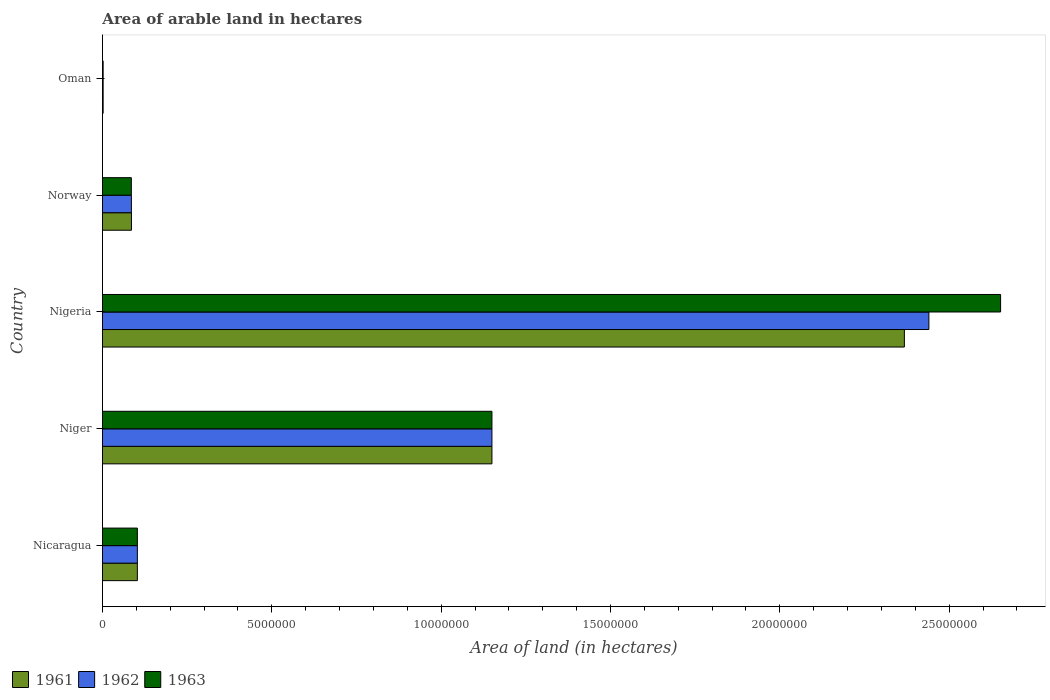How many groups of bars are there?
Make the answer very short. 5. Are the number of bars per tick equal to the number of legend labels?
Ensure brevity in your answer.  Yes. How many bars are there on the 1st tick from the top?
Offer a terse response. 3. What is the label of the 5th group of bars from the top?
Provide a short and direct response. Nicaragua. In how many cases, is the number of bars for a given country not equal to the number of legend labels?
Provide a succinct answer. 0. What is the total arable land in 1963 in Niger?
Your answer should be very brief. 1.15e+07. Across all countries, what is the maximum total arable land in 1963?
Provide a succinct answer. 2.65e+07. In which country was the total arable land in 1963 maximum?
Offer a terse response. Nigeria. In which country was the total arable land in 1961 minimum?
Give a very brief answer. Oman. What is the total total arable land in 1962 in the graph?
Offer a very short reply. 3.78e+07. What is the difference between the total arable land in 1961 in Niger and that in Norway?
Give a very brief answer. 1.06e+07. What is the difference between the total arable land in 1962 in Niger and the total arable land in 1963 in Nigeria?
Make the answer very short. -1.50e+07. What is the average total arable land in 1961 per country?
Your response must be concise. 7.42e+06. What is the difference between the total arable land in 1961 and total arable land in 1963 in Norway?
Ensure brevity in your answer.  4000. What is the ratio of the total arable land in 1961 in Niger to that in Oman?
Ensure brevity in your answer.  574.95. Is the difference between the total arable land in 1961 in Nicaragua and Norway greater than the difference between the total arable land in 1963 in Nicaragua and Norway?
Keep it short and to the point. No. What is the difference between the highest and the second highest total arable land in 1963?
Provide a succinct answer. 1.50e+07. What is the difference between the highest and the lowest total arable land in 1962?
Provide a short and direct response. 2.44e+07. Is it the case that in every country, the sum of the total arable land in 1963 and total arable land in 1961 is greater than the total arable land in 1962?
Ensure brevity in your answer.  Yes. How many countries are there in the graph?
Provide a succinct answer. 5. What is the difference between two consecutive major ticks on the X-axis?
Make the answer very short. 5.00e+06. Are the values on the major ticks of X-axis written in scientific E-notation?
Offer a very short reply. No. Does the graph contain grids?
Offer a terse response. No. How many legend labels are there?
Provide a succinct answer. 3. What is the title of the graph?
Ensure brevity in your answer.  Area of arable land in hectares. What is the label or title of the X-axis?
Offer a terse response. Area of land (in hectares). What is the label or title of the Y-axis?
Offer a very short reply. Country. What is the Area of land (in hectares) in 1961 in Nicaragua?
Offer a terse response. 1.03e+06. What is the Area of land (in hectares) of 1962 in Nicaragua?
Ensure brevity in your answer.  1.03e+06. What is the Area of land (in hectares) in 1963 in Nicaragua?
Keep it short and to the point. 1.03e+06. What is the Area of land (in hectares) of 1961 in Niger?
Give a very brief answer. 1.15e+07. What is the Area of land (in hectares) of 1962 in Niger?
Offer a very short reply. 1.15e+07. What is the Area of land (in hectares) in 1963 in Niger?
Your answer should be compact. 1.15e+07. What is the Area of land (in hectares) in 1961 in Nigeria?
Provide a short and direct response. 2.37e+07. What is the Area of land (in hectares) of 1962 in Nigeria?
Offer a very short reply. 2.44e+07. What is the Area of land (in hectares) in 1963 in Nigeria?
Offer a terse response. 2.65e+07. What is the Area of land (in hectares) in 1961 in Norway?
Your response must be concise. 8.56e+05. What is the Area of land (in hectares) in 1962 in Norway?
Keep it short and to the point. 8.54e+05. What is the Area of land (in hectares) in 1963 in Norway?
Offer a very short reply. 8.52e+05. What is the Area of land (in hectares) of 1961 in Oman?
Give a very brief answer. 2.00e+04. What is the Area of land (in hectares) of 1962 in Oman?
Provide a succinct answer. 2.00e+04. What is the Area of land (in hectares) of 1963 in Oman?
Your answer should be very brief. 2.00e+04. Across all countries, what is the maximum Area of land (in hectares) in 1961?
Provide a short and direct response. 2.37e+07. Across all countries, what is the maximum Area of land (in hectares) in 1962?
Give a very brief answer. 2.44e+07. Across all countries, what is the maximum Area of land (in hectares) in 1963?
Provide a succinct answer. 2.65e+07. What is the total Area of land (in hectares) of 1961 in the graph?
Offer a very short reply. 3.71e+07. What is the total Area of land (in hectares) of 1962 in the graph?
Keep it short and to the point. 3.78e+07. What is the total Area of land (in hectares) of 1963 in the graph?
Ensure brevity in your answer.  3.99e+07. What is the difference between the Area of land (in hectares) of 1961 in Nicaragua and that in Niger?
Your answer should be very brief. -1.05e+07. What is the difference between the Area of land (in hectares) of 1962 in Nicaragua and that in Niger?
Keep it short and to the point. -1.05e+07. What is the difference between the Area of land (in hectares) in 1963 in Nicaragua and that in Niger?
Provide a short and direct response. -1.05e+07. What is the difference between the Area of land (in hectares) in 1961 in Nicaragua and that in Nigeria?
Offer a very short reply. -2.26e+07. What is the difference between the Area of land (in hectares) of 1962 in Nicaragua and that in Nigeria?
Provide a short and direct response. -2.34e+07. What is the difference between the Area of land (in hectares) in 1963 in Nicaragua and that in Nigeria?
Give a very brief answer. -2.55e+07. What is the difference between the Area of land (in hectares) in 1961 in Nicaragua and that in Norway?
Make the answer very short. 1.74e+05. What is the difference between the Area of land (in hectares) of 1962 in Nicaragua and that in Norway?
Provide a short and direct response. 1.76e+05. What is the difference between the Area of land (in hectares) of 1963 in Nicaragua and that in Norway?
Provide a short and direct response. 1.78e+05. What is the difference between the Area of land (in hectares) in 1961 in Nicaragua and that in Oman?
Make the answer very short. 1.01e+06. What is the difference between the Area of land (in hectares) of 1962 in Nicaragua and that in Oman?
Make the answer very short. 1.01e+06. What is the difference between the Area of land (in hectares) of 1963 in Nicaragua and that in Oman?
Provide a short and direct response. 1.01e+06. What is the difference between the Area of land (in hectares) in 1961 in Niger and that in Nigeria?
Your response must be concise. -1.22e+07. What is the difference between the Area of land (in hectares) in 1962 in Niger and that in Nigeria?
Your response must be concise. -1.29e+07. What is the difference between the Area of land (in hectares) in 1963 in Niger and that in Nigeria?
Your response must be concise. -1.50e+07. What is the difference between the Area of land (in hectares) in 1961 in Niger and that in Norway?
Provide a short and direct response. 1.06e+07. What is the difference between the Area of land (in hectares) in 1962 in Niger and that in Norway?
Offer a very short reply. 1.06e+07. What is the difference between the Area of land (in hectares) of 1963 in Niger and that in Norway?
Make the answer very short. 1.06e+07. What is the difference between the Area of land (in hectares) of 1961 in Niger and that in Oman?
Make the answer very short. 1.15e+07. What is the difference between the Area of land (in hectares) of 1962 in Niger and that in Oman?
Offer a very short reply. 1.15e+07. What is the difference between the Area of land (in hectares) in 1963 in Niger and that in Oman?
Provide a succinct answer. 1.15e+07. What is the difference between the Area of land (in hectares) of 1961 in Nigeria and that in Norway?
Ensure brevity in your answer.  2.28e+07. What is the difference between the Area of land (in hectares) of 1962 in Nigeria and that in Norway?
Your answer should be compact. 2.35e+07. What is the difference between the Area of land (in hectares) in 1963 in Nigeria and that in Norway?
Ensure brevity in your answer.  2.57e+07. What is the difference between the Area of land (in hectares) of 1961 in Nigeria and that in Oman?
Keep it short and to the point. 2.37e+07. What is the difference between the Area of land (in hectares) of 1962 in Nigeria and that in Oman?
Offer a very short reply. 2.44e+07. What is the difference between the Area of land (in hectares) of 1963 in Nigeria and that in Oman?
Give a very brief answer. 2.65e+07. What is the difference between the Area of land (in hectares) in 1961 in Norway and that in Oman?
Give a very brief answer. 8.36e+05. What is the difference between the Area of land (in hectares) in 1962 in Norway and that in Oman?
Your answer should be compact. 8.34e+05. What is the difference between the Area of land (in hectares) in 1963 in Norway and that in Oman?
Ensure brevity in your answer.  8.32e+05. What is the difference between the Area of land (in hectares) in 1961 in Nicaragua and the Area of land (in hectares) in 1962 in Niger?
Your response must be concise. -1.05e+07. What is the difference between the Area of land (in hectares) of 1961 in Nicaragua and the Area of land (in hectares) of 1963 in Niger?
Your response must be concise. -1.05e+07. What is the difference between the Area of land (in hectares) in 1962 in Nicaragua and the Area of land (in hectares) in 1963 in Niger?
Give a very brief answer. -1.05e+07. What is the difference between the Area of land (in hectares) of 1961 in Nicaragua and the Area of land (in hectares) of 1962 in Nigeria?
Offer a very short reply. -2.34e+07. What is the difference between the Area of land (in hectares) of 1961 in Nicaragua and the Area of land (in hectares) of 1963 in Nigeria?
Provide a short and direct response. -2.55e+07. What is the difference between the Area of land (in hectares) in 1962 in Nicaragua and the Area of land (in hectares) in 1963 in Nigeria?
Give a very brief answer. -2.55e+07. What is the difference between the Area of land (in hectares) of 1961 in Nicaragua and the Area of land (in hectares) of 1962 in Norway?
Provide a succinct answer. 1.76e+05. What is the difference between the Area of land (in hectares) of 1961 in Nicaragua and the Area of land (in hectares) of 1963 in Norway?
Provide a short and direct response. 1.78e+05. What is the difference between the Area of land (in hectares) in 1962 in Nicaragua and the Area of land (in hectares) in 1963 in Norway?
Give a very brief answer. 1.78e+05. What is the difference between the Area of land (in hectares) in 1961 in Nicaragua and the Area of land (in hectares) in 1962 in Oman?
Make the answer very short. 1.01e+06. What is the difference between the Area of land (in hectares) in 1961 in Nicaragua and the Area of land (in hectares) in 1963 in Oman?
Your answer should be compact. 1.01e+06. What is the difference between the Area of land (in hectares) in 1962 in Nicaragua and the Area of land (in hectares) in 1963 in Oman?
Your response must be concise. 1.01e+06. What is the difference between the Area of land (in hectares) of 1961 in Niger and the Area of land (in hectares) of 1962 in Nigeria?
Provide a short and direct response. -1.29e+07. What is the difference between the Area of land (in hectares) of 1961 in Niger and the Area of land (in hectares) of 1963 in Nigeria?
Provide a succinct answer. -1.50e+07. What is the difference between the Area of land (in hectares) of 1962 in Niger and the Area of land (in hectares) of 1963 in Nigeria?
Keep it short and to the point. -1.50e+07. What is the difference between the Area of land (in hectares) in 1961 in Niger and the Area of land (in hectares) in 1962 in Norway?
Provide a short and direct response. 1.06e+07. What is the difference between the Area of land (in hectares) in 1961 in Niger and the Area of land (in hectares) in 1963 in Norway?
Offer a very short reply. 1.06e+07. What is the difference between the Area of land (in hectares) in 1962 in Niger and the Area of land (in hectares) in 1963 in Norway?
Your answer should be compact. 1.06e+07. What is the difference between the Area of land (in hectares) in 1961 in Niger and the Area of land (in hectares) in 1962 in Oman?
Keep it short and to the point. 1.15e+07. What is the difference between the Area of land (in hectares) in 1961 in Niger and the Area of land (in hectares) in 1963 in Oman?
Ensure brevity in your answer.  1.15e+07. What is the difference between the Area of land (in hectares) in 1962 in Niger and the Area of land (in hectares) in 1963 in Oman?
Offer a terse response. 1.15e+07. What is the difference between the Area of land (in hectares) in 1961 in Nigeria and the Area of land (in hectares) in 1962 in Norway?
Keep it short and to the point. 2.28e+07. What is the difference between the Area of land (in hectares) of 1961 in Nigeria and the Area of land (in hectares) of 1963 in Norway?
Your answer should be very brief. 2.28e+07. What is the difference between the Area of land (in hectares) in 1962 in Nigeria and the Area of land (in hectares) in 1963 in Norway?
Ensure brevity in your answer.  2.35e+07. What is the difference between the Area of land (in hectares) in 1961 in Nigeria and the Area of land (in hectares) in 1962 in Oman?
Offer a terse response. 2.37e+07. What is the difference between the Area of land (in hectares) in 1961 in Nigeria and the Area of land (in hectares) in 1963 in Oman?
Your answer should be compact. 2.37e+07. What is the difference between the Area of land (in hectares) of 1962 in Nigeria and the Area of land (in hectares) of 1963 in Oman?
Provide a succinct answer. 2.44e+07. What is the difference between the Area of land (in hectares) of 1961 in Norway and the Area of land (in hectares) of 1962 in Oman?
Keep it short and to the point. 8.36e+05. What is the difference between the Area of land (in hectares) of 1961 in Norway and the Area of land (in hectares) of 1963 in Oman?
Ensure brevity in your answer.  8.36e+05. What is the difference between the Area of land (in hectares) in 1962 in Norway and the Area of land (in hectares) in 1963 in Oman?
Offer a very short reply. 8.34e+05. What is the average Area of land (in hectares) of 1961 per country?
Provide a succinct answer. 7.42e+06. What is the average Area of land (in hectares) in 1962 per country?
Your response must be concise. 7.56e+06. What is the average Area of land (in hectares) in 1963 per country?
Keep it short and to the point. 7.98e+06. What is the difference between the Area of land (in hectares) in 1961 and Area of land (in hectares) in 1962 in Nicaragua?
Make the answer very short. 0. What is the difference between the Area of land (in hectares) of 1962 and Area of land (in hectares) of 1963 in Nicaragua?
Give a very brief answer. 0. What is the difference between the Area of land (in hectares) in 1961 and Area of land (in hectares) in 1962 in Niger?
Give a very brief answer. 0. What is the difference between the Area of land (in hectares) in 1961 and Area of land (in hectares) in 1963 in Niger?
Provide a succinct answer. 0. What is the difference between the Area of land (in hectares) of 1961 and Area of land (in hectares) of 1962 in Nigeria?
Provide a succinct answer. -7.23e+05. What is the difference between the Area of land (in hectares) of 1961 and Area of land (in hectares) of 1963 in Nigeria?
Give a very brief answer. -2.84e+06. What is the difference between the Area of land (in hectares) of 1962 and Area of land (in hectares) of 1963 in Nigeria?
Offer a terse response. -2.12e+06. What is the difference between the Area of land (in hectares) of 1961 and Area of land (in hectares) of 1962 in Norway?
Provide a succinct answer. 2000. What is the difference between the Area of land (in hectares) in 1961 and Area of land (in hectares) in 1963 in Norway?
Give a very brief answer. 4000. What is the difference between the Area of land (in hectares) in 1961 and Area of land (in hectares) in 1963 in Oman?
Offer a very short reply. 0. What is the ratio of the Area of land (in hectares) of 1961 in Nicaragua to that in Niger?
Ensure brevity in your answer.  0.09. What is the ratio of the Area of land (in hectares) in 1962 in Nicaragua to that in Niger?
Give a very brief answer. 0.09. What is the ratio of the Area of land (in hectares) in 1963 in Nicaragua to that in Niger?
Make the answer very short. 0.09. What is the ratio of the Area of land (in hectares) of 1961 in Nicaragua to that in Nigeria?
Make the answer very short. 0.04. What is the ratio of the Area of land (in hectares) in 1962 in Nicaragua to that in Nigeria?
Give a very brief answer. 0.04. What is the ratio of the Area of land (in hectares) of 1963 in Nicaragua to that in Nigeria?
Keep it short and to the point. 0.04. What is the ratio of the Area of land (in hectares) of 1961 in Nicaragua to that in Norway?
Keep it short and to the point. 1.2. What is the ratio of the Area of land (in hectares) of 1962 in Nicaragua to that in Norway?
Provide a short and direct response. 1.21. What is the ratio of the Area of land (in hectares) in 1963 in Nicaragua to that in Norway?
Your answer should be compact. 1.21. What is the ratio of the Area of land (in hectares) in 1961 in Nicaragua to that in Oman?
Offer a terse response. 51.5. What is the ratio of the Area of land (in hectares) of 1962 in Nicaragua to that in Oman?
Keep it short and to the point. 51.5. What is the ratio of the Area of land (in hectares) of 1963 in Nicaragua to that in Oman?
Your answer should be compact. 51.5. What is the ratio of the Area of land (in hectares) of 1961 in Niger to that in Nigeria?
Your answer should be compact. 0.49. What is the ratio of the Area of land (in hectares) of 1962 in Niger to that in Nigeria?
Provide a short and direct response. 0.47. What is the ratio of the Area of land (in hectares) of 1963 in Niger to that in Nigeria?
Your response must be concise. 0.43. What is the ratio of the Area of land (in hectares) of 1961 in Niger to that in Norway?
Give a very brief answer. 13.43. What is the ratio of the Area of land (in hectares) of 1962 in Niger to that in Norway?
Offer a terse response. 13.46. What is the ratio of the Area of land (in hectares) of 1963 in Niger to that in Norway?
Make the answer very short. 13.5. What is the ratio of the Area of land (in hectares) of 1961 in Niger to that in Oman?
Keep it short and to the point. 574.95. What is the ratio of the Area of land (in hectares) of 1962 in Niger to that in Oman?
Ensure brevity in your answer.  574.95. What is the ratio of the Area of land (in hectares) of 1963 in Niger to that in Oman?
Give a very brief answer. 574.95. What is the ratio of the Area of land (in hectares) of 1961 in Nigeria to that in Norway?
Make the answer very short. 27.66. What is the ratio of the Area of land (in hectares) of 1962 in Nigeria to that in Norway?
Offer a very short reply. 28.57. What is the ratio of the Area of land (in hectares) of 1963 in Nigeria to that in Norway?
Your answer should be compact. 31.12. What is the ratio of the Area of land (in hectares) in 1961 in Nigeria to that in Oman?
Ensure brevity in your answer.  1183.83. What is the ratio of the Area of land (in hectares) of 1962 in Nigeria to that in Oman?
Provide a succinct answer. 1220. What is the ratio of the Area of land (in hectares) in 1963 in Nigeria to that in Oman?
Give a very brief answer. 1325.85. What is the ratio of the Area of land (in hectares) in 1961 in Norway to that in Oman?
Give a very brief answer. 42.8. What is the ratio of the Area of land (in hectares) in 1962 in Norway to that in Oman?
Your answer should be compact. 42.7. What is the ratio of the Area of land (in hectares) in 1963 in Norway to that in Oman?
Your response must be concise. 42.6. What is the difference between the highest and the second highest Area of land (in hectares) of 1961?
Your response must be concise. 1.22e+07. What is the difference between the highest and the second highest Area of land (in hectares) in 1962?
Provide a short and direct response. 1.29e+07. What is the difference between the highest and the second highest Area of land (in hectares) of 1963?
Your response must be concise. 1.50e+07. What is the difference between the highest and the lowest Area of land (in hectares) in 1961?
Make the answer very short. 2.37e+07. What is the difference between the highest and the lowest Area of land (in hectares) of 1962?
Your response must be concise. 2.44e+07. What is the difference between the highest and the lowest Area of land (in hectares) of 1963?
Make the answer very short. 2.65e+07. 